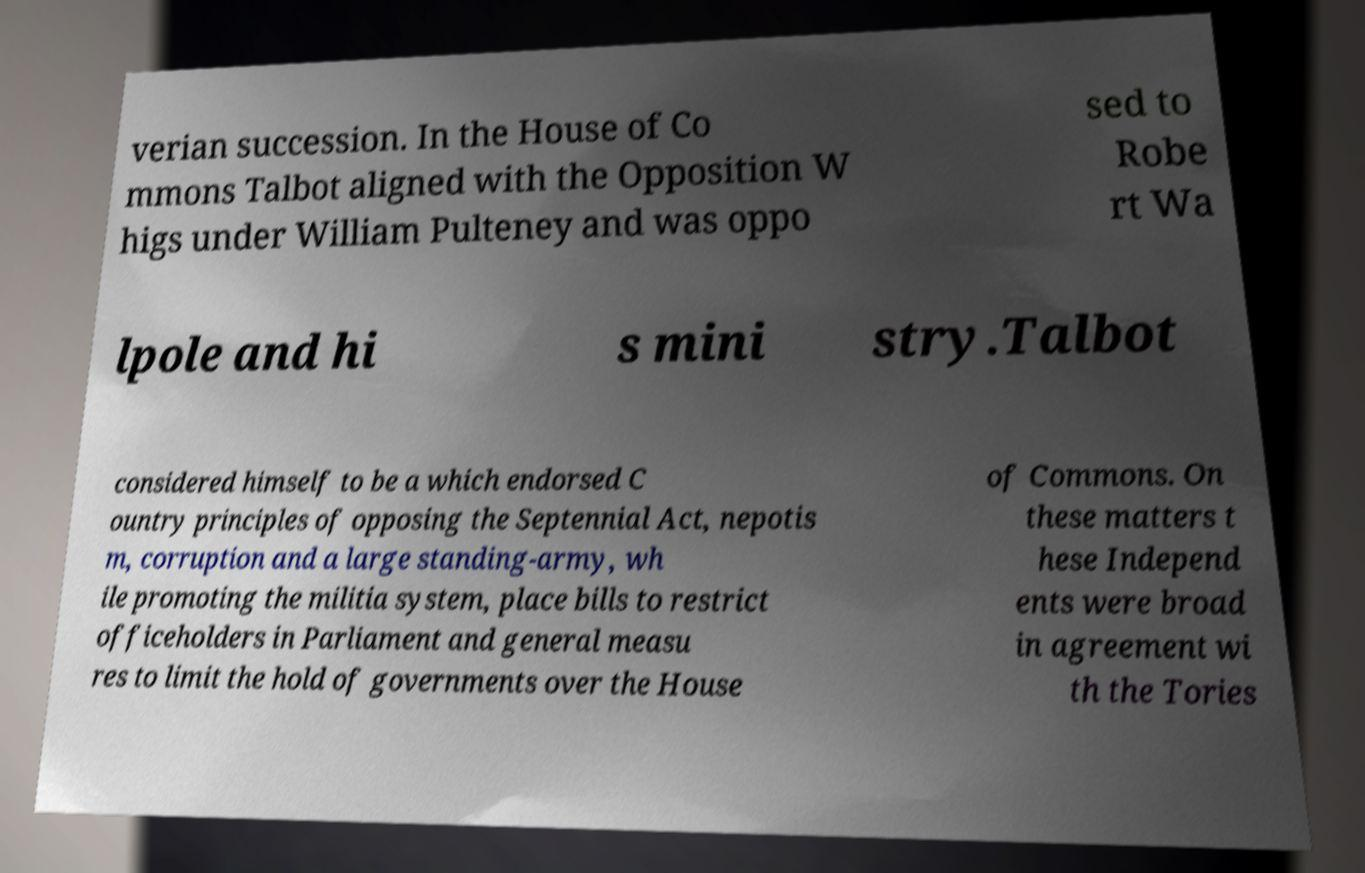Please identify and transcribe the text found in this image. verian succession. In the House of Co mmons Talbot aligned with the Opposition W higs under William Pulteney and was oppo sed to Robe rt Wa lpole and hi s mini stry.Talbot considered himself to be a which endorsed C ountry principles of opposing the Septennial Act, nepotis m, corruption and a large standing-army, wh ile promoting the militia system, place bills to restrict officeholders in Parliament and general measu res to limit the hold of governments over the House of Commons. On these matters t hese Independ ents were broad in agreement wi th the Tories 